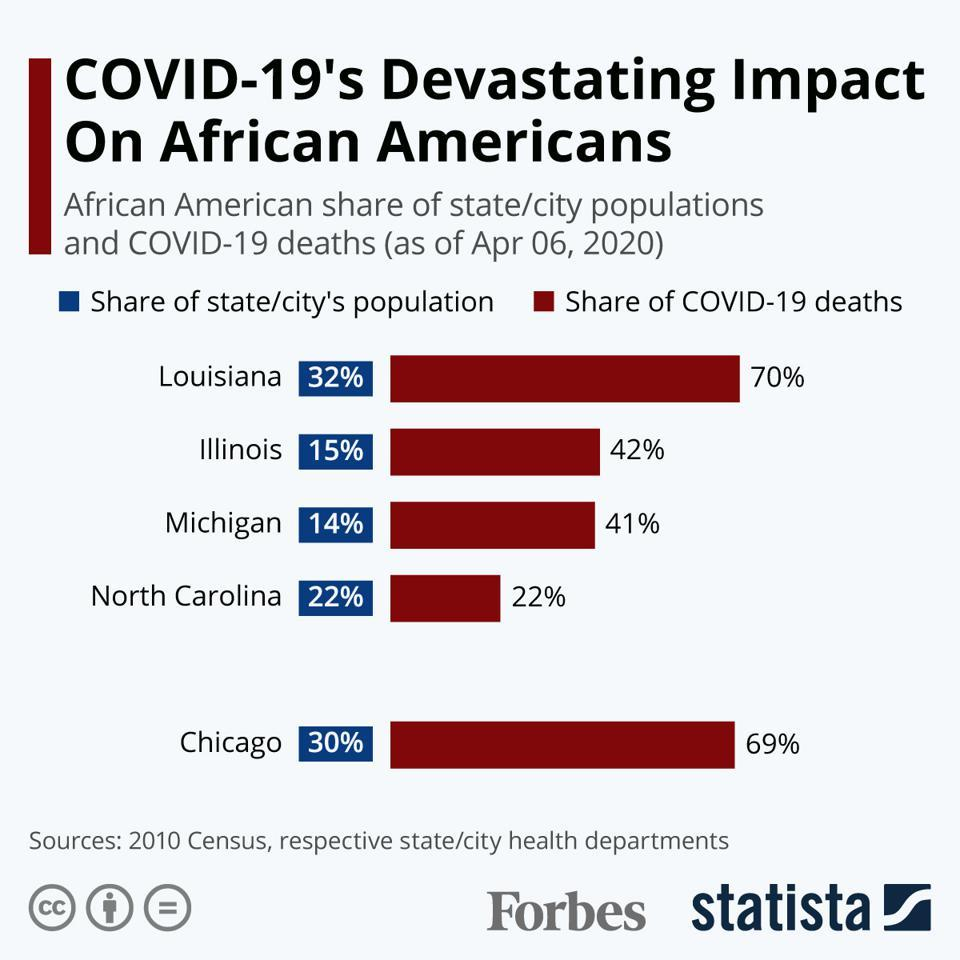Mention a couple of crucial points in this snapshot. Louisiana reported the highest number of Covid-19 deaths among African Americans as of April 06, 2020. According to recent estimates, approximately 30% of the population in Chicago is Afro-American. Louisiana is the state in America that contributes to the highest percentage of the African American population. According to data, the state of Michigan in America has the lowest percentage of its population that is African American. As of April 6, 2020, approximately 22% of the COVID-19 deaths among African Americans were reported in North Carolina. 